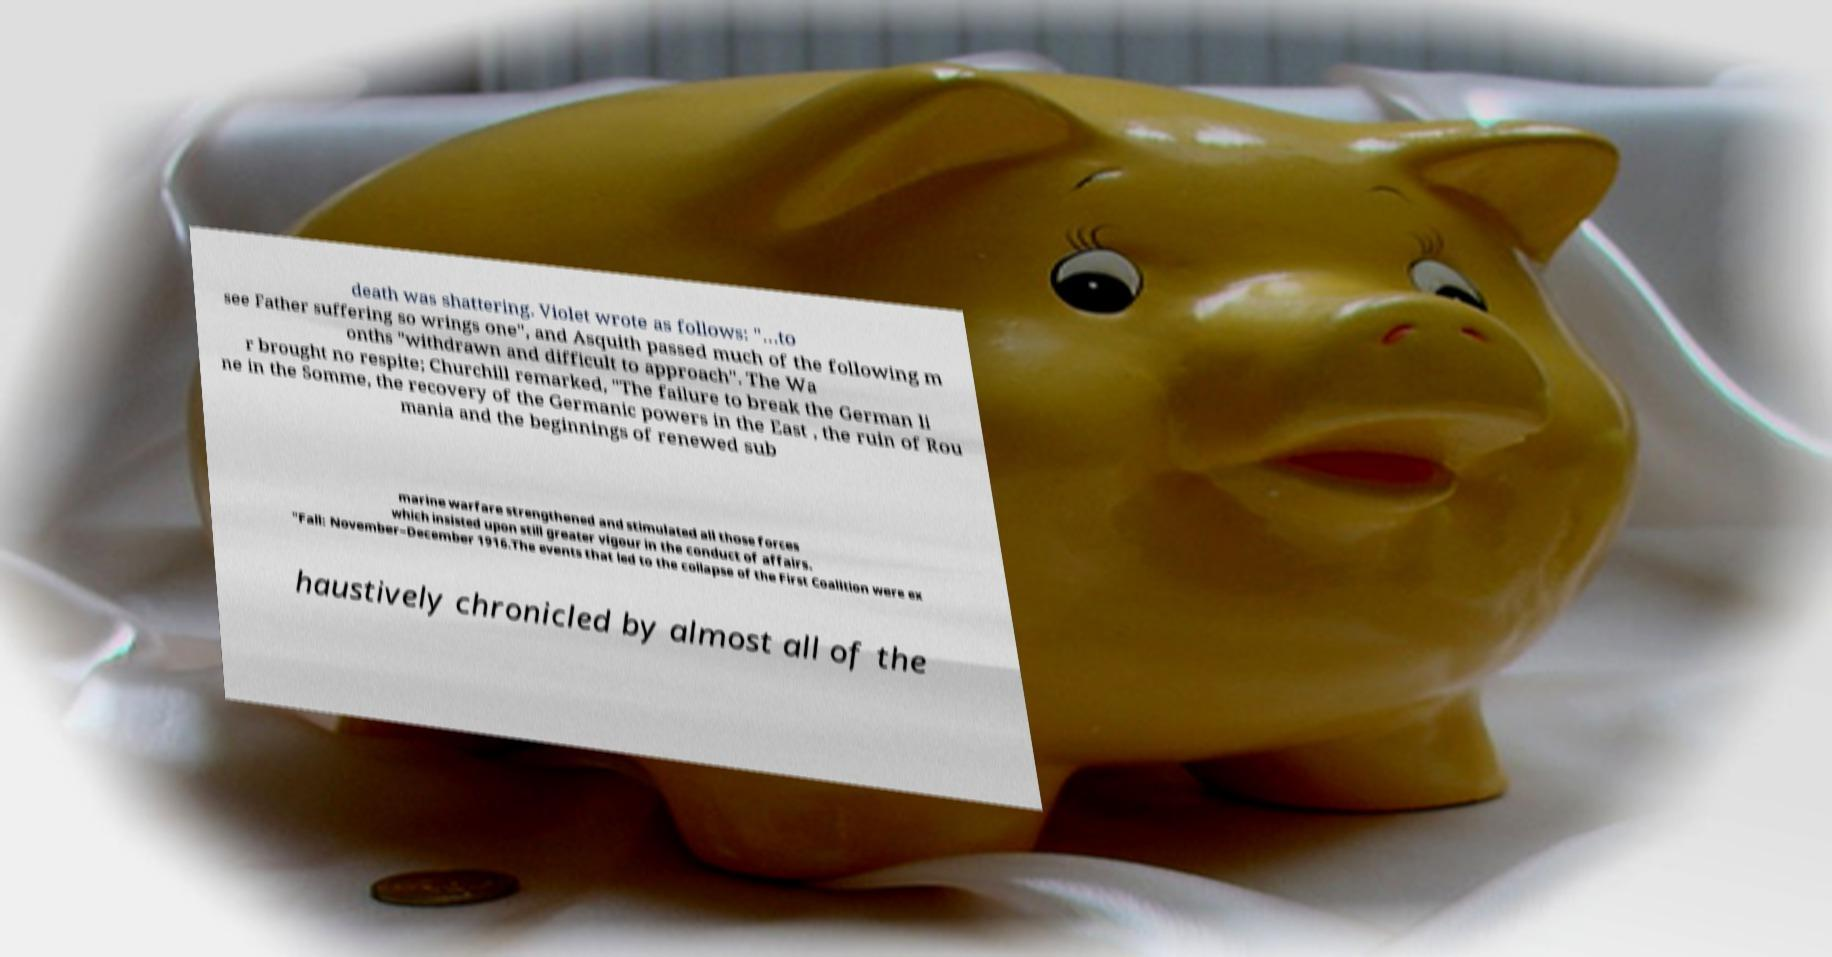For documentation purposes, I need the text within this image transcribed. Could you provide that? death was shattering. Violet wrote as follows: "…to see Father suffering so wrings one", and Asquith passed much of the following m onths "withdrawn and difficult to approach". The Wa r brought no respite; Churchill remarked, "The failure to break the German li ne in the Somme, the recovery of the Germanic powers in the East , the ruin of Rou mania and the beginnings of renewed sub marine warfare strengthened and stimulated all those forces which insisted upon still greater vigour in the conduct of affairs. "Fall: November–December 1916.The events that led to the collapse of the First Coalition were ex haustively chronicled by almost all of the 